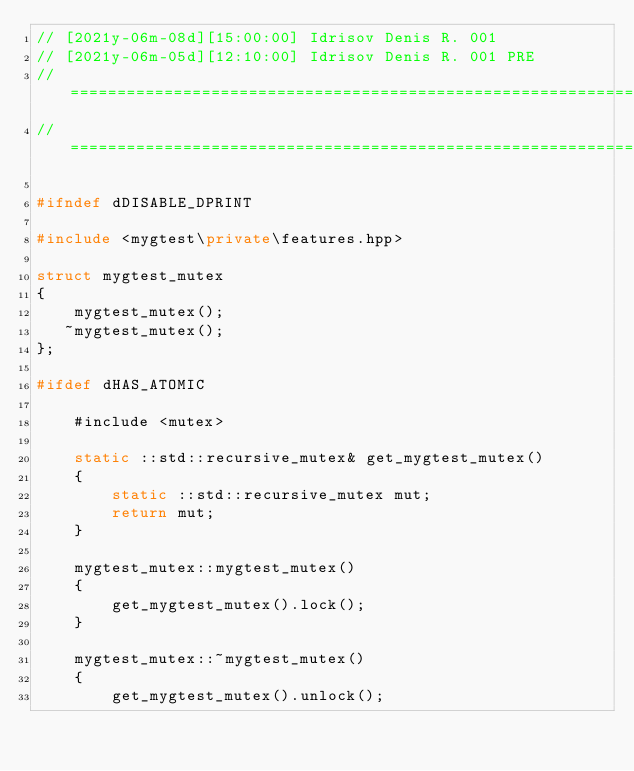<code> <loc_0><loc_0><loc_500><loc_500><_C++_>// [2021y-06m-08d][15:00:00] Idrisov Denis R. 001
// [2021y-06m-05d][12:10:00] Idrisov Denis R. 001 PRE
//==============================================================================
//==============================================================================

#ifndef dDISABLE_DPRINT

#include <mygtest\private\features.hpp>

struct mygtest_mutex
{
    mygtest_mutex();
   ~mygtest_mutex();
};

#ifdef dHAS_ATOMIC

    #include <mutex>

    static ::std::recursive_mutex& get_mygtest_mutex()
    {
        static ::std::recursive_mutex mut;
        return mut;
    }

    mygtest_mutex::mygtest_mutex()
    {
        get_mygtest_mutex().lock();
    }

    mygtest_mutex::~mygtest_mutex()
    {
        get_mygtest_mutex().unlock();</code> 